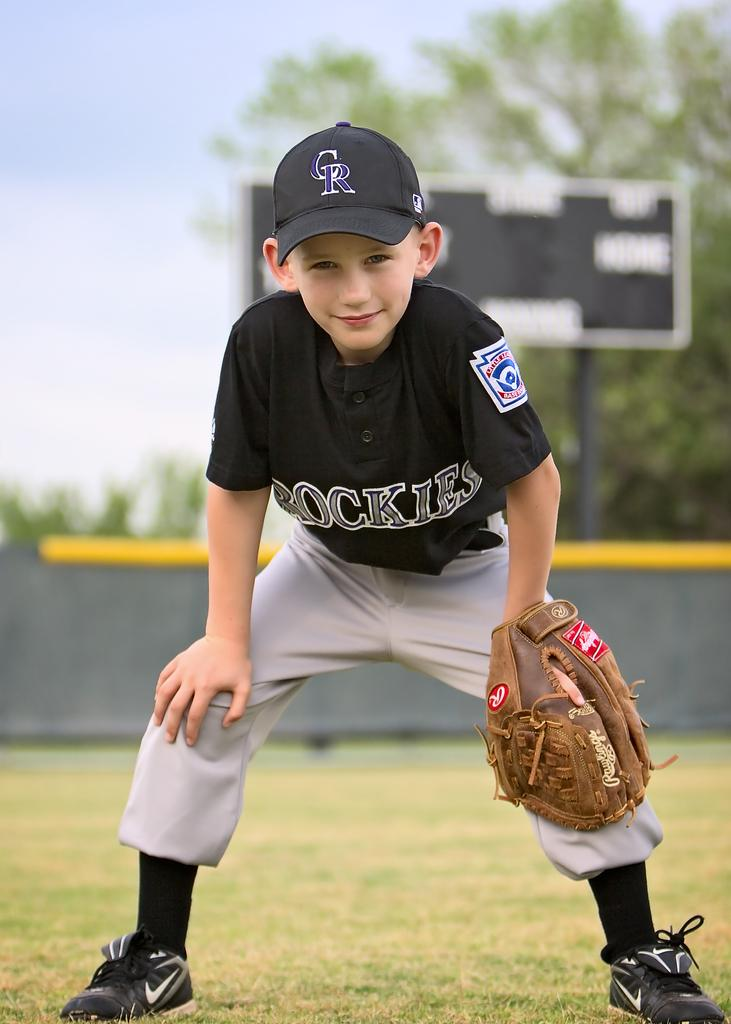<image>
Describe the image concisely. A boy with a Colorado Rockies hat and jersey on with a Rawlings glove on. 